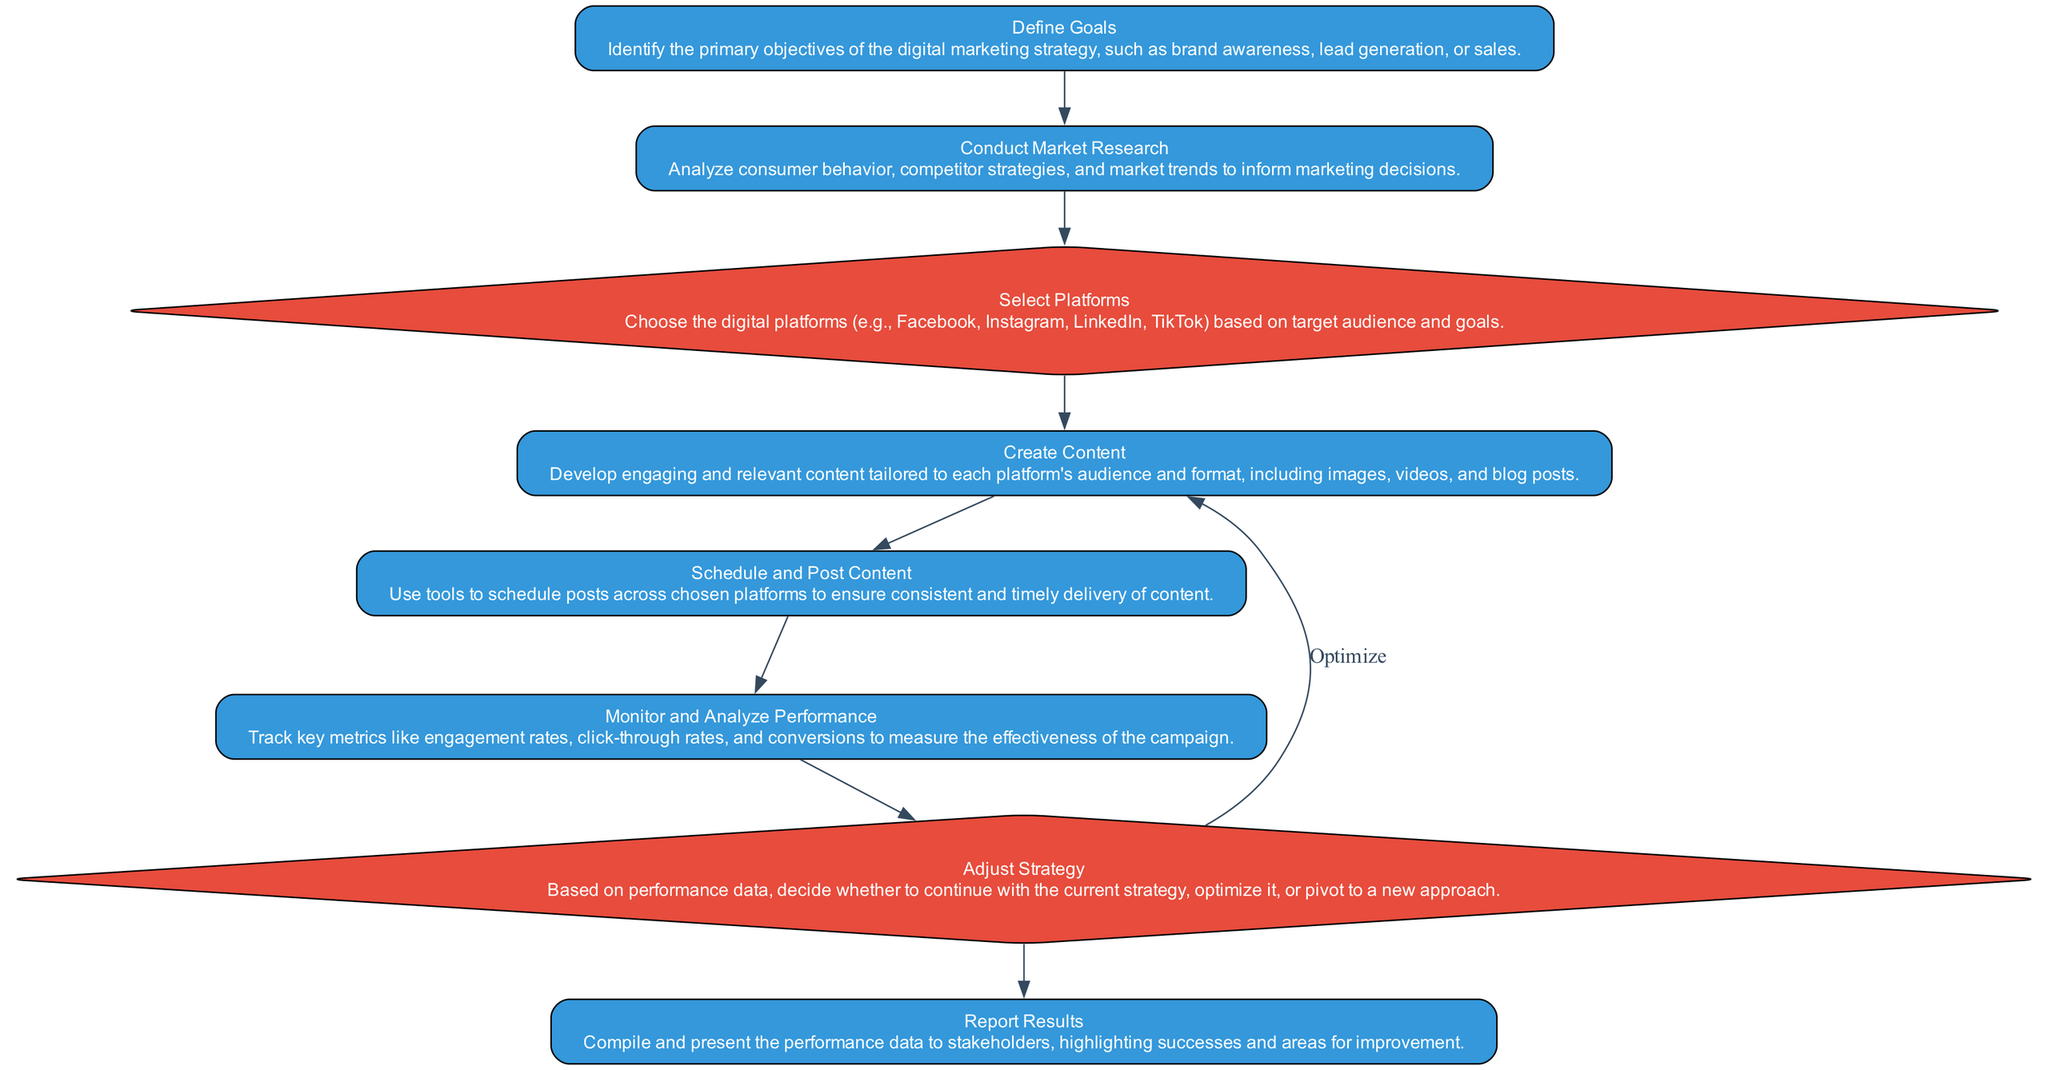What is the first step in the workflow? The first step in the workflow is labeled "Define Goals", which indicates that it is the initial action taken before any other steps.
Answer: Define Goals How many actions are there in the workflow? By counting the steps labeled as actions in the diagram, we see that there are five actions: "Define Goals", "Conduct Market Research", "Create Content", "Schedule and Post Content", and "Monitor and Analyze Performance".
Answer: Five What type of node follows "Select Platforms"? After "Select Platforms", the next node is an action step labeled "Create Content". Therefore, the node following it is of type action.
Answer: Action What decision can be made after "Monitor and Analyze Performance"? Following "Monitor and Analyze Performance", the diagram presents the decision step labeled "Adjust Strategy". This indicates that a strategic decision regarding the marketing plan needs to be made based on the performance metrics tracked.
Answer: Adjust Strategy How does the workflow return from "Adjust Strategy" to "Create Content"? The workflow has a loop that connects "Adjust Strategy" back to "Create Content", labeled with the term "Optimize". This indicates that if the decision is made to optimize the strategy, the process can iterate back to content creation.
Answer: Optimize What are the primary objectives to define in the first step? The objectives referred to in "Define Goals" can include brand awareness, lead generation, or sales, as identified in the description of this step.
Answer: Brand awareness, lead generation, or sales What is the last action in the workflow? The last action in the workflow is labeled "Report Results", which indicates the concluding step in the marketing strategy execution process.
Answer: Report Results What kind of metrics are tracked during "Monitor and Analyze Performance"? During the "Monitor and Analyze Performance" action, key metrics like engagement rates, click-through rates, and conversions are tracked to gauge campaign effectiveness.
Answer: Engagement rates, click-through rates, and conversions How many decision points are present in the workflow? There are two decision points in the workflow: "Select Platforms" and "Adjust Strategy". This indicates moments where choices must be made based on specific criteria.
Answer: Two 